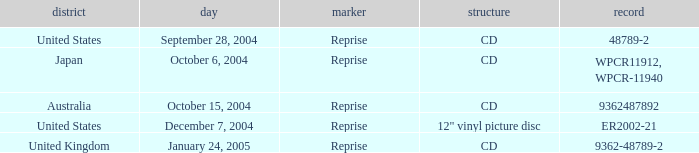Name the catalogue for australia 9362487892.0. 